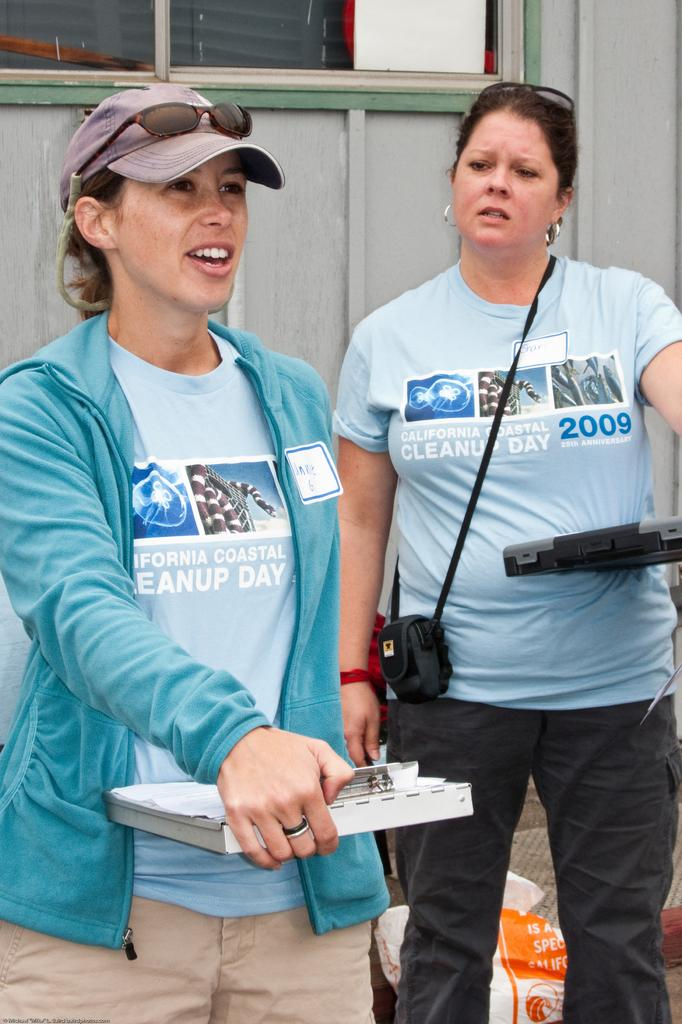<image>
Write a terse but informative summary of the picture. Woman wearing a shirt which has the year 2009. 